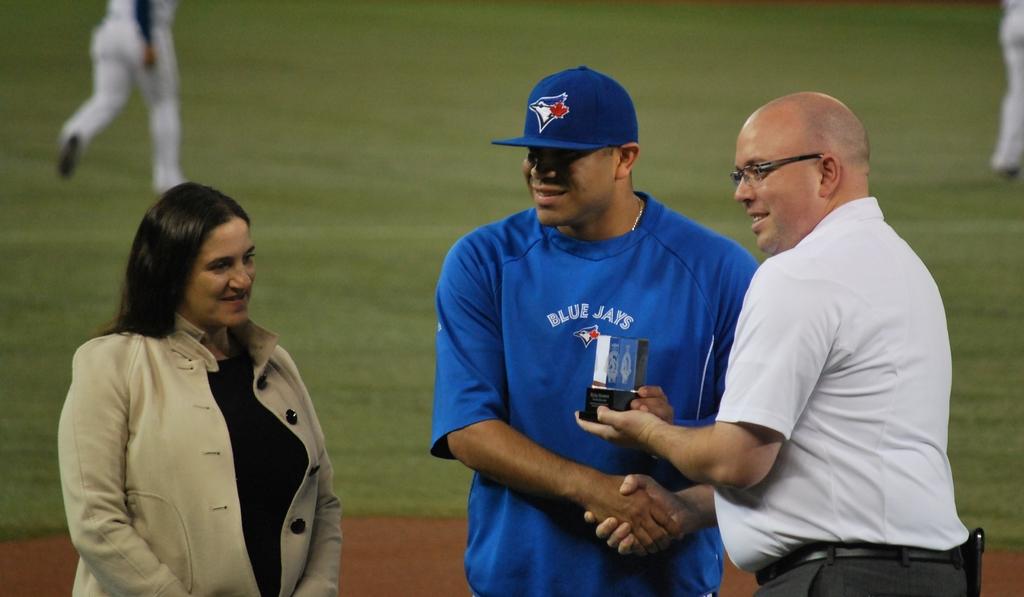What team is the player from that is receiving the award?
Offer a terse response. Blue jays. 